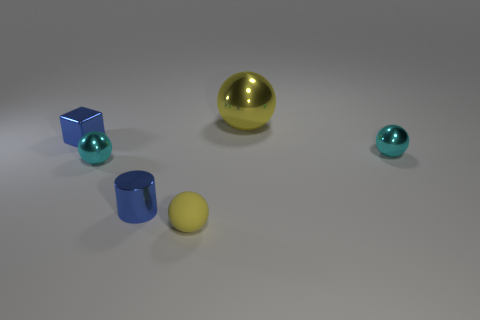Assuming these objects are part of a set, what sort of game or activity might they be used for? Considering their varying sizes and colors, these objects could be part of an educational set designed for activities such as color recognition, sorting by size, or spatial reasoning exercises. They seem ideal for interactive learning tasks or even as components in a hands-on puzzle or matching game. 